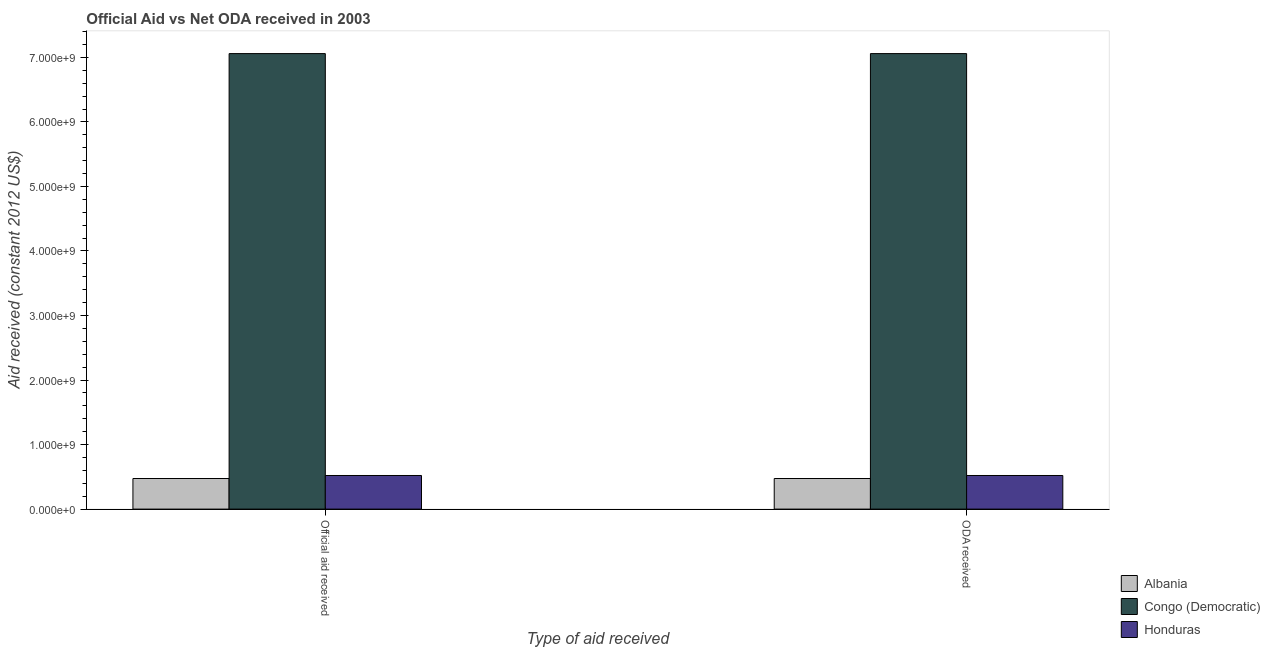How many groups of bars are there?
Give a very brief answer. 2. Are the number of bars on each tick of the X-axis equal?
Your response must be concise. Yes. How many bars are there on the 2nd tick from the left?
Give a very brief answer. 3. How many bars are there on the 1st tick from the right?
Your response must be concise. 3. What is the label of the 1st group of bars from the left?
Provide a succinct answer. Official aid received. What is the official aid received in Congo (Democratic)?
Your answer should be compact. 7.06e+09. Across all countries, what is the maximum official aid received?
Offer a terse response. 7.06e+09. Across all countries, what is the minimum oda received?
Your response must be concise. 4.74e+08. In which country was the official aid received maximum?
Your answer should be very brief. Congo (Democratic). In which country was the official aid received minimum?
Your answer should be very brief. Albania. What is the total oda received in the graph?
Keep it short and to the point. 8.05e+09. What is the difference between the official aid received in Honduras and that in Congo (Democratic)?
Offer a very short reply. -6.54e+09. What is the difference between the oda received in Albania and the official aid received in Honduras?
Provide a succinct answer. -4.67e+07. What is the average official aid received per country?
Offer a very short reply. 2.68e+09. What is the difference between the official aid received and oda received in Honduras?
Keep it short and to the point. 0. What is the ratio of the official aid received in Albania to that in Honduras?
Keep it short and to the point. 0.91. What does the 2nd bar from the left in ODA received represents?
Your response must be concise. Congo (Democratic). What does the 2nd bar from the right in ODA received represents?
Your answer should be very brief. Congo (Democratic). Are all the bars in the graph horizontal?
Offer a very short reply. No. How many countries are there in the graph?
Provide a short and direct response. 3. Are the values on the major ticks of Y-axis written in scientific E-notation?
Give a very brief answer. Yes. Does the graph contain any zero values?
Your response must be concise. No. What is the title of the graph?
Your answer should be compact. Official Aid vs Net ODA received in 2003 . Does "New Caledonia" appear as one of the legend labels in the graph?
Provide a succinct answer. No. What is the label or title of the X-axis?
Make the answer very short. Type of aid received. What is the label or title of the Y-axis?
Make the answer very short. Aid received (constant 2012 US$). What is the Aid received (constant 2012 US$) in Albania in Official aid received?
Offer a very short reply. 4.74e+08. What is the Aid received (constant 2012 US$) of Congo (Democratic) in Official aid received?
Your response must be concise. 7.06e+09. What is the Aid received (constant 2012 US$) in Honduras in Official aid received?
Give a very brief answer. 5.21e+08. What is the Aid received (constant 2012 US$) in Albania in ODA received?
Provide a short and direct response. 4.74e+08. What is the Aid received (constant 2012 US$) in Congo (Democratic) in ODA received?
Offer a terse response. 7.06e+09. What is the Aid received (constant 2012 US$) in Honduras in ODA received?
Provide a succinct answer. 5.21e+08. Across all Type of aid received, what is the maximum Aid received (constant 2012 US$) of Albania?
Provide a succinct answer. 4.74e+08. Across all Type of aid received, what is the maximum Aid received (constant 2012 US$) in Congo (Democratic)?
Offer a very short reply. 7.06e+09. Across all Type of aid received, what is the maximum Aid received (constant 2012 US$) of Honduras?
Make the answer very short. 5.21e+08. Across all Type of aid received, what is the minimum Aid received (constant 2012 US$) in Albania?
Provide a short and direct response. 4.74e+08. Across all Type of aid received, what is the minimum Aid received (constant 2012 US$) in Congo (Democratic)?
Provide a succinct answer. 7.06e+09. Across all Type of aid received, what is the minimum Aid received (constant 2012 US$) in Honduras?
Provide a short and direct response. 5.21e+08. What is the total Aid received (constant 2012 US$) of Albania in the graph?
Your answer should be compact. 9.48e+08. What is the total Aid received (constant 2012 US$) in Congo (Democratic) in the graph?
Offer a very short reply. 1.41e+1. What is the total Aid received (constant 2012 US$) of Honduras in the graph?
Your answer should be very brief. 1.04e+09. What is the difference between the Aid received (constant 2012 US$) in Honduras in Official aid received and that in ODA received?
Offer a terse response. 0. What is the difference between the Aid received (constant 2012 US$) of Albania in Official aid received and the Aid received (constant 2012 US$) of Congo (Democratic) in ODA received?
Your answer should be compact. -6.58e+09. What is the difference between the Aid received (constant 2012 US$) in Albania in Official aid received and the Aid received (constant 2012 US$) in Honduras in ODA received?
Your answer should be compact. -4.67e+07. What is the difference between the Aid received (constant 2012 US$) in Congo (Democratic) in Official aid received and the Aid received (constant 2012 US$) in Honduras in ODA received?
Your answer should be very brief. 6.54e+09. What is the average Aid received (constant 2012 US$) in Albania per Type of aid received?
Your answer should be compact. 4.74e+08. What is the average Aid received (constant 2012 US$) in Congo (Democratic) per Type of aid received?
Offer a terse response. 7.06e+09. What is the average Aid received (constant 2012 US$) in Honduras per Type of aid received?
Your answer should be very brief. 5.21e+08. What is the difference between the Aid received (constant 2012 US$) of Albania and Aid received (constant 2012 US$) of Congo (Democratic) in Official aid received?
Your response must be concise. -6.58e+09. What is the difference between the Aid received (constant 2012 US$) of Albania and Aid received (constant 2012 US$) of Honduras in Official aid received?
Your response must be concise. -4.67e+07. What is the difference between the Aid received (constant 2012 US$) of Congo (Democratic) and Aid received (constant 2012 US$) of Honduras in Official aid received?
Your answer should be compact. 6.54e+09. What is the difference between the Aid received (constant 2012 US$) in Albania and Aid received (constant 2012 US$) in Congo (Democratic) in ODA received?
Offer a terse response. -6.58e+09. What is the difference between the Aid received (constant 2012 US$) in Albania and Aid received (constant 2012 US$) in Honduras in ODA received?
Ensure brevity in your answer.  -4.67e+07. What is the difference between the Aid received (constant 2012 US$) of Congo (Democratic) and Aid received (constant 2012 US$) of Honduras in ODA received?
Your answer should be compact. 6.54e+09. What is the ratio of the Aid received (constant 2012 US$) of Albania in Official aid received to that in ODA received?
Ensure brevity in your answer.  1. What is the ratio of the Aid received (constant 2012 US$) of Congo (Democratic) in Official aid received to that in ODA received?
Make the answer very short. 1. What is the ratio of the Aid received (constant 2012 US$) in Honduras in Official aid received to that in ODA received?
Offer a terse response. 1. What is the difference between the highest and the second highest Aid received (constant 2012 US$) in Congo (Democratic)?
Your answer should be very brief. 0. What is the difference between the highest and the lowest Aid received (constant 2012 US$) in Albania?
Your response must be concise. 0. What is the difference between the highest and the lowest Aid received (constant 2012 US$) of Congo (Democratic)?
Your answer should be compact. 0. 